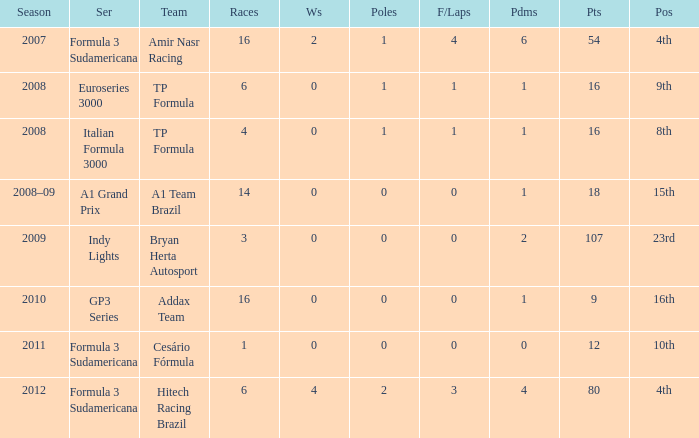What team did he compete for in the GP3 series? Addax Team. 